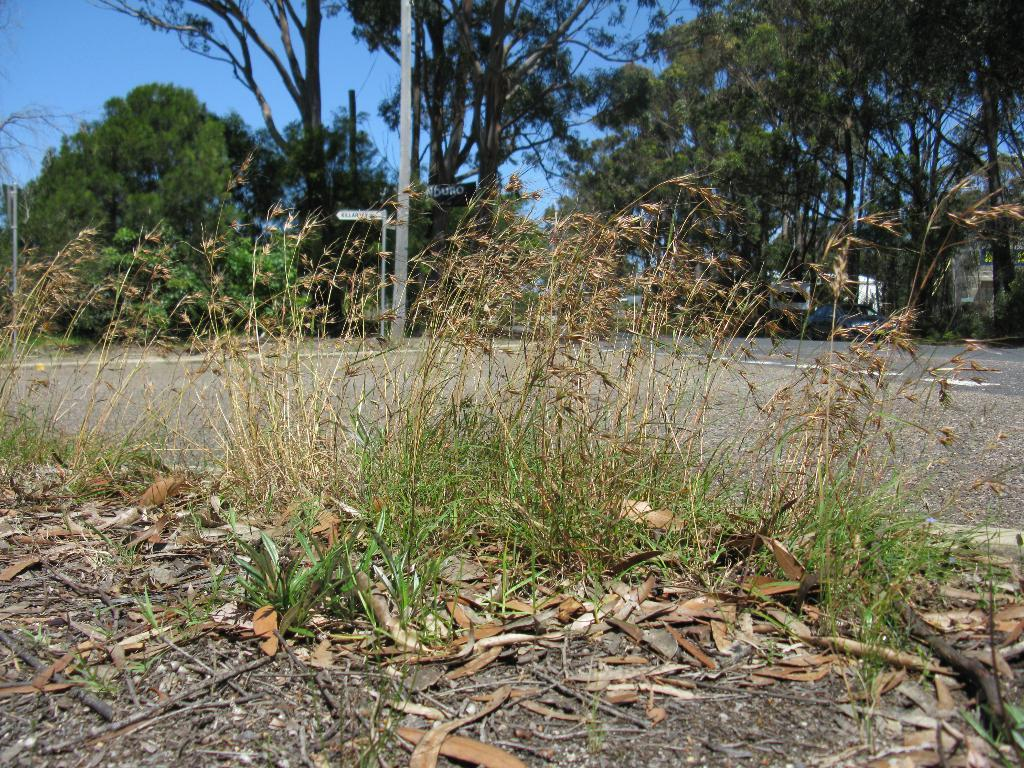What type of living organisms can be seen in the image? Plants and leaves are visible in the image. What type of man-made structure can be seen in the image? There is a road in the image. What can be seen in the background of the image? Boards attached to poles, trees, and the sky are visible in the background of the image. Can you tell me how many goats are grazing on the floor in the image? There are no goats present in the image, and the floor is not visible. What type of rose can be seen in the image? There is no rose present in the image. 